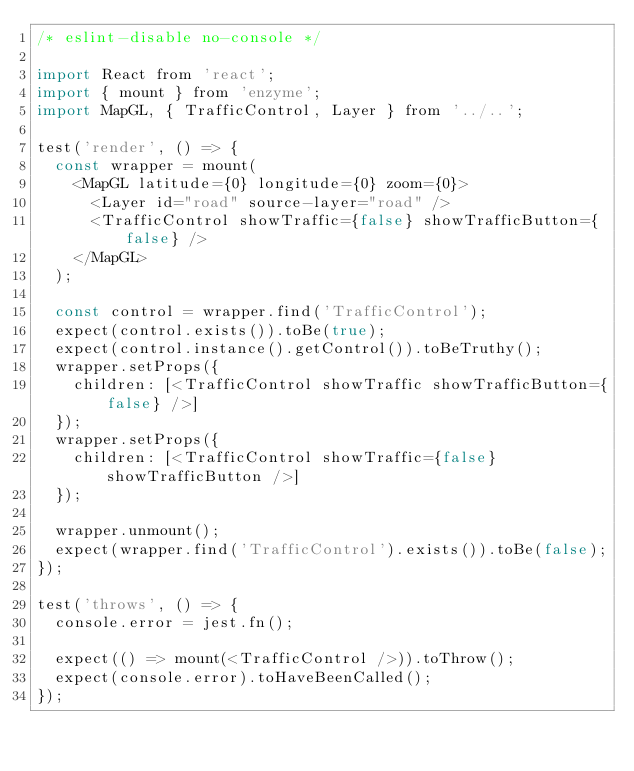Convert code to text. <code><loc_0><loc_0><loc_500><loc_500><_JavaScript_>/* eslint-disable no-console */

import React from 'react';
import { mount } from 'enzyme';
import MapGL, { TrafficControl, Layer } from '../..';

test('render', () => {
  const wrapper = mount(
    <MapGL latitude={0} longitude={0} zoom={0}>
      <Layer id="road" source-layer="road" />
      <TrafficControl showTraffic={false} showTrafficButton={false} />
    </MapGL>
  );

  const control = wrapper.find('TrafficControl');
  expect(control.exists()).toBe(true);
  expect(control.instance().getControl()).toBeTruthy();
  wrapper.setProps({
    children: [<TrafficControl showTraffic showTrafficButton={false} />]
  });
  wrapper.setProps({
    children: [<TrafficControl showTraffic={false} showTrafficButton />]
  });

  wrapper.unmount();
  expect(wrapper.find('TrafficControl').exists()).toBe(false);
});

test('throws', () => {
  console.error = jest.fn();

  expect(() => mount(<TrafficControl />)).toThrow();
  expect(console.error).toHaveBeenCalled();
});
</code> 